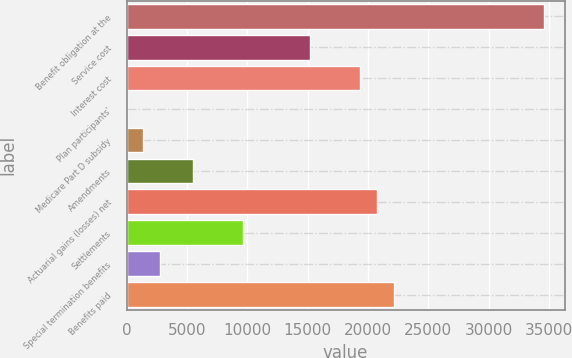Convert chart. <chart><loc_0><loc_0><loc_500><loc_500><bar_chart><fcel>Benefit obligation at the<fcel>Service cost<fcel>Interest cost<fcel>Plan participants'<fcel>Medicare Part D subsidy<fcel>Amendments<fcel>Actuarial gains (losses) net<fcel>Settlements<fcel>Special termination benefits<fcel>Benefits paid<nl><fcel>34594.5<fcel>15221.7<fcel>19373<fcel>0.27<fcel>1384.04<fcel>5535.35<fcel>20756.8<fcel>9686.66<fcel>2767.81<fcel>22140.6<nl></chart> 